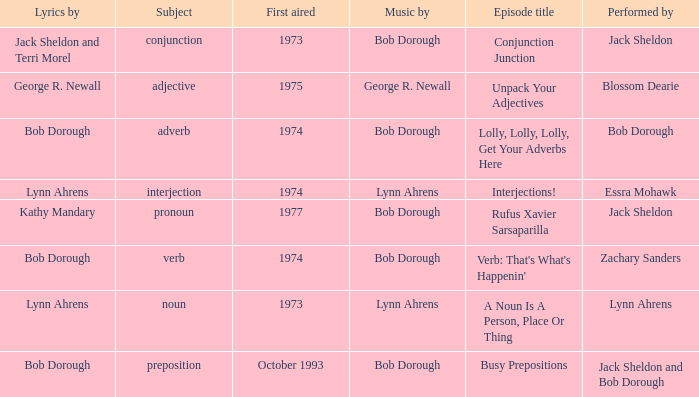When zachary sanders is the performer how many first aired are there? 1.0. 